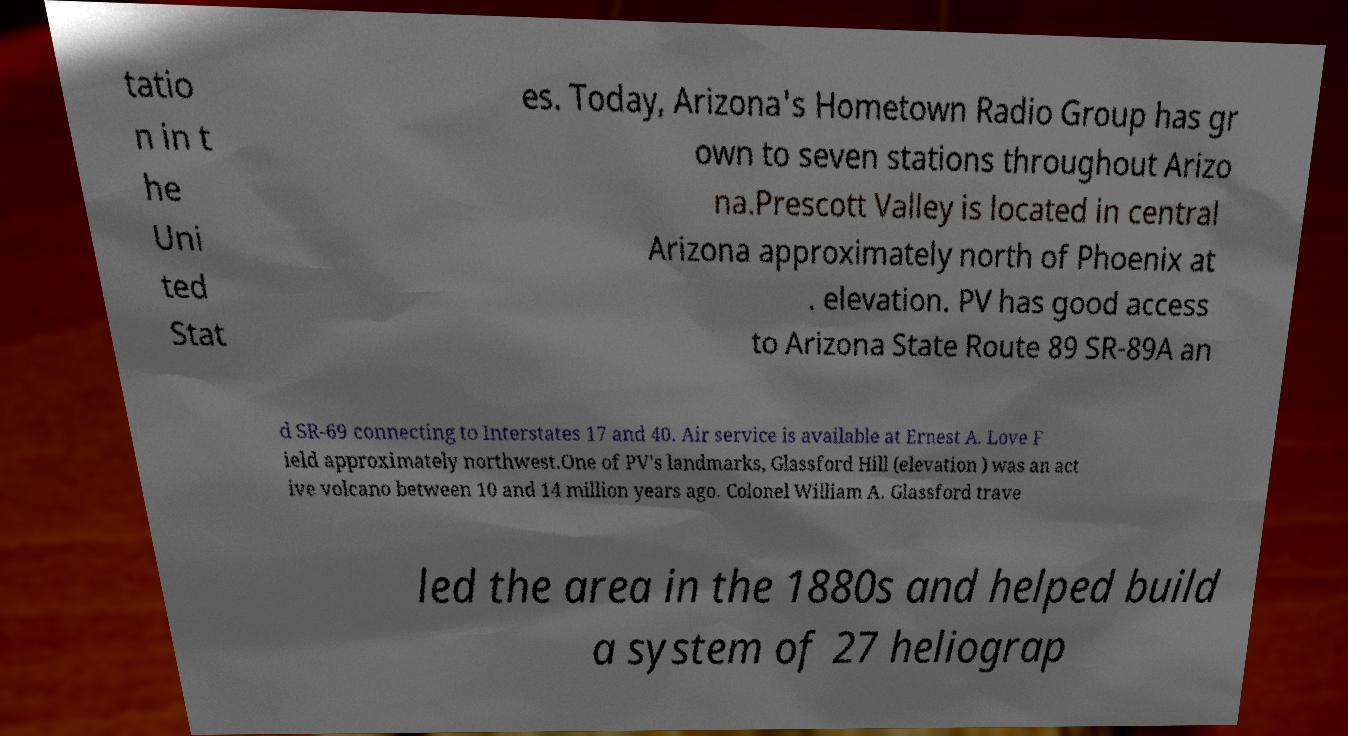What messages or text are displayed in this image? I need them in a readable, typed format. tatio n in t he Uni ted Stat es. Today, Arizona's Hometown Radio Group has gr own to seven stations throughout Arizo na.Prescott Valley is located in central Arizona approximately north of Phoenix at . elevation. PV has good access to Arizona State Route 89 SR-89A an d SR-69 connecting to Interstates 17 and 40. Air service is available at Ernest A. Love F ield approximately northwest.One of PV's landmarks, Glassford Hill (elevation ) was an act ive volcano between 10 and 14 million years ago. Colonel William A. Glassford trave led the area in the 1880s and helped build a system of 27 heliograp 